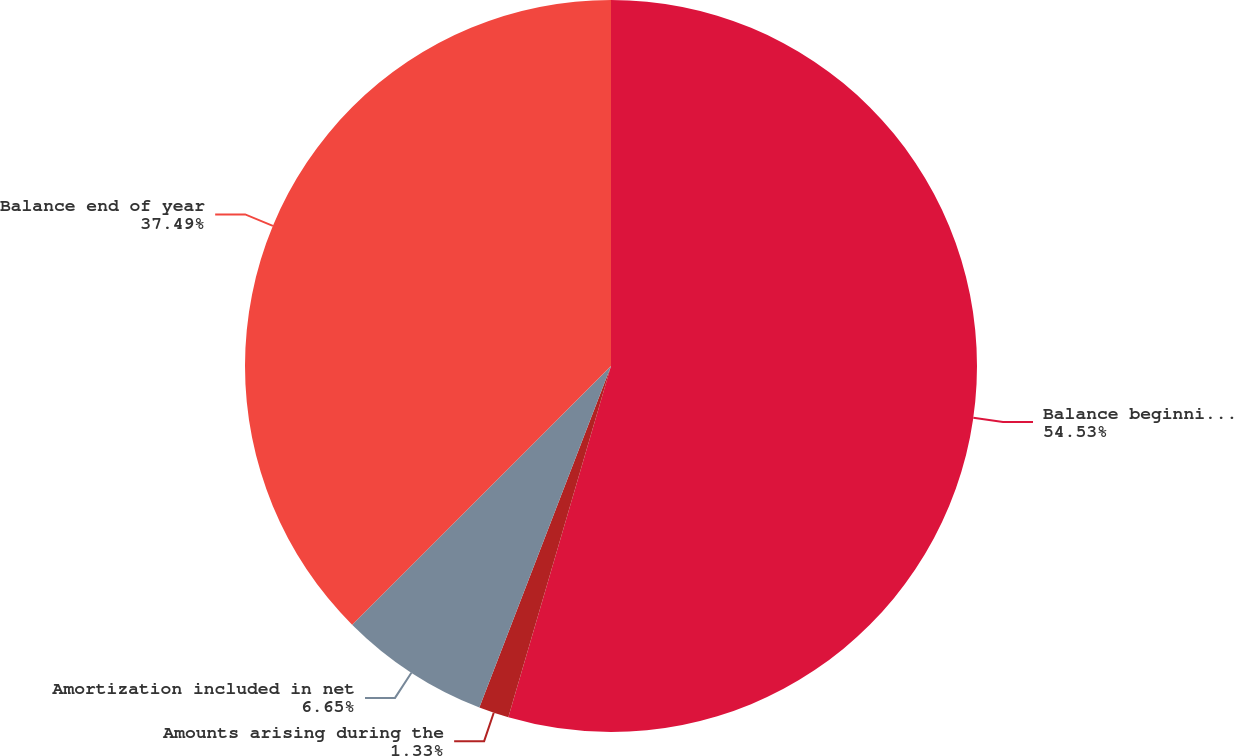<chart> <loc_0><loc_0><loc_500><loc_500><pie_chart><fcel>Balance beginning of year<fcel>Amounts arising during the<fcel>Amortization included in net<fcel>Balance end of year<nl><fcel>54.52%<fcel>1.33%<fcel>6.65%<fcel>37.49%<nl></chart> 